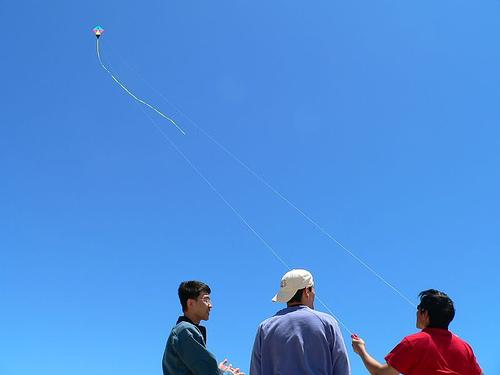Which color shirt does the person flying the kite wear? red 